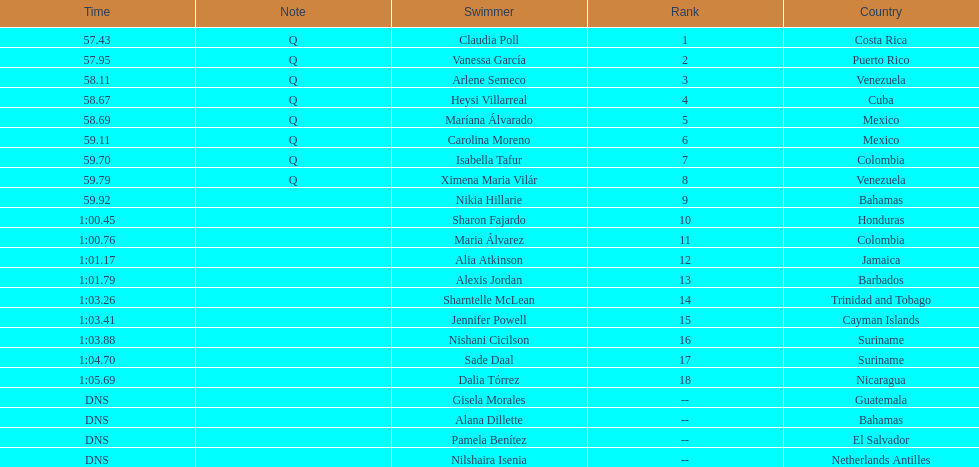How many swimmers did not swim? 4. 